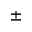<formula> <loc_0><loc_0><loc_500><loc_500>\pm</formula> 